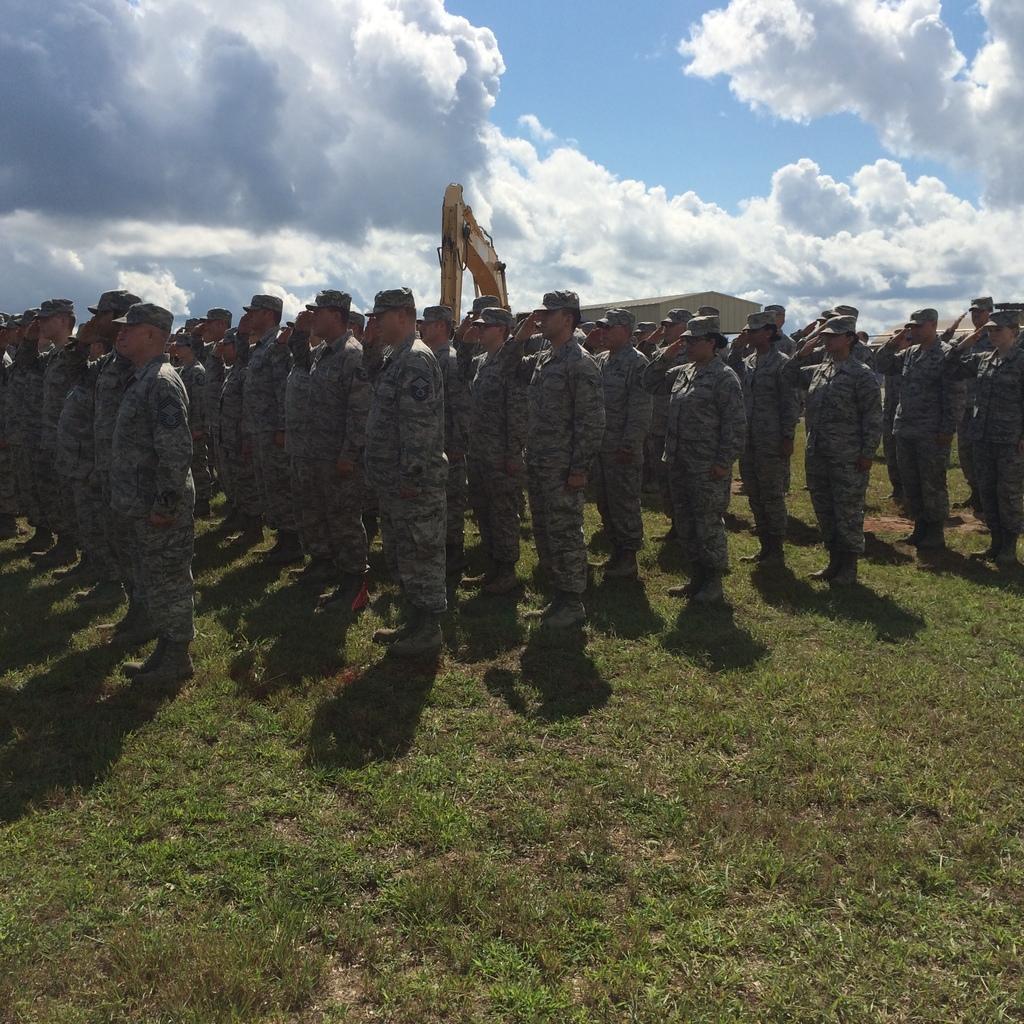Can you describe this image briefly? In this image I can see a group of soldiers on the ground. In the background I can see a crane, shed and the sky. This image is taken may be during a day on the ground. 